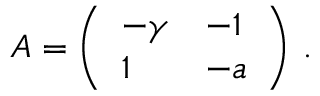Convert formula to latex. <formula><loc_0><loc_0><loc_500><loc_500>A = \left ( \begin{array} { l l } { - \gamma } & { - 1 } \\ { 1 } & { - a } \end{array} \right ) \, .</formula> 